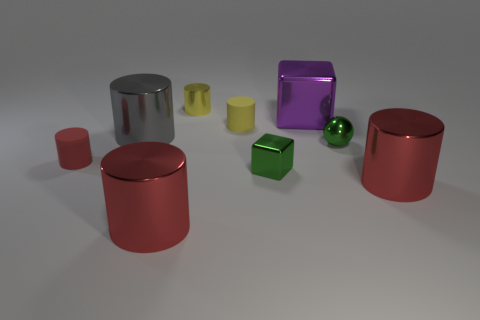Subtract all small metal cylinders. How many cylinders are left? 5 Subtract all blue balls. How many yellow cylinders are left? 2 Add 1 small purple metallic cylinders. How many objects exist? 10 Subtract all gray cylinders. How many cylinders are left? 5 Subtract 1 blocks. How many blocks are left? 1 Subtract all green cylinders. Subtract all blue blocks. How many cylinders are left? 6 Subtract all metallic balls. Subtract all gray objects. How many objects are left? 7 Add 4 small things. How many small things are left? 9 Add 1 yellow cylinders. How many yellow cylinders exist? 3 Subtract 0 purple balls. How many objects are left? 9 